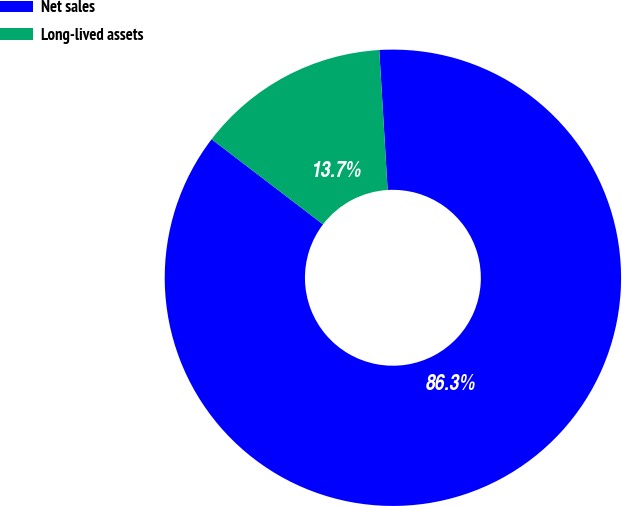<chart> <loc_0><loc_0><loc_500><loc_500><pie_chart><fcel>Net sales<fcel>Long-lived assets<nl><fcel>86.34%<fcel>13.66%<nl></chart> 